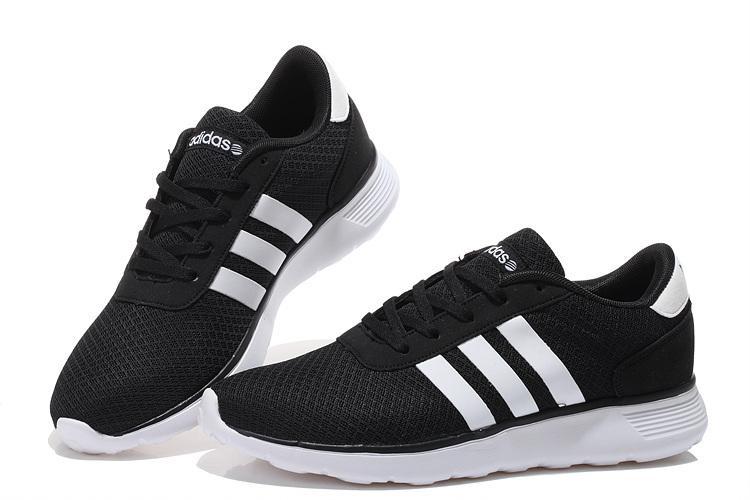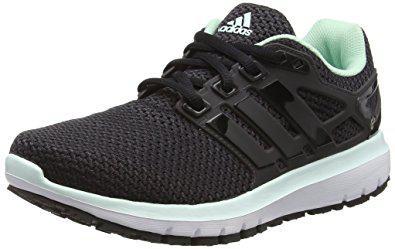The first image is the image on the left, the second image is the image on the right. Evaluate the accuracy of this statement regarding the images: "There is a part of a human visible on at least one of the images.". Is it true? Answer yes or no. No. 